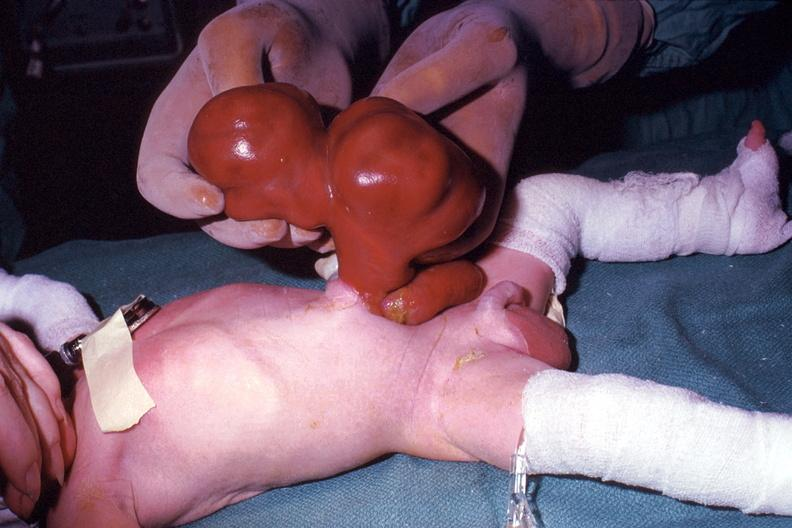does omphalocele show a photo taken during life large lesion?
Answer the question using a single word or phrase. No 